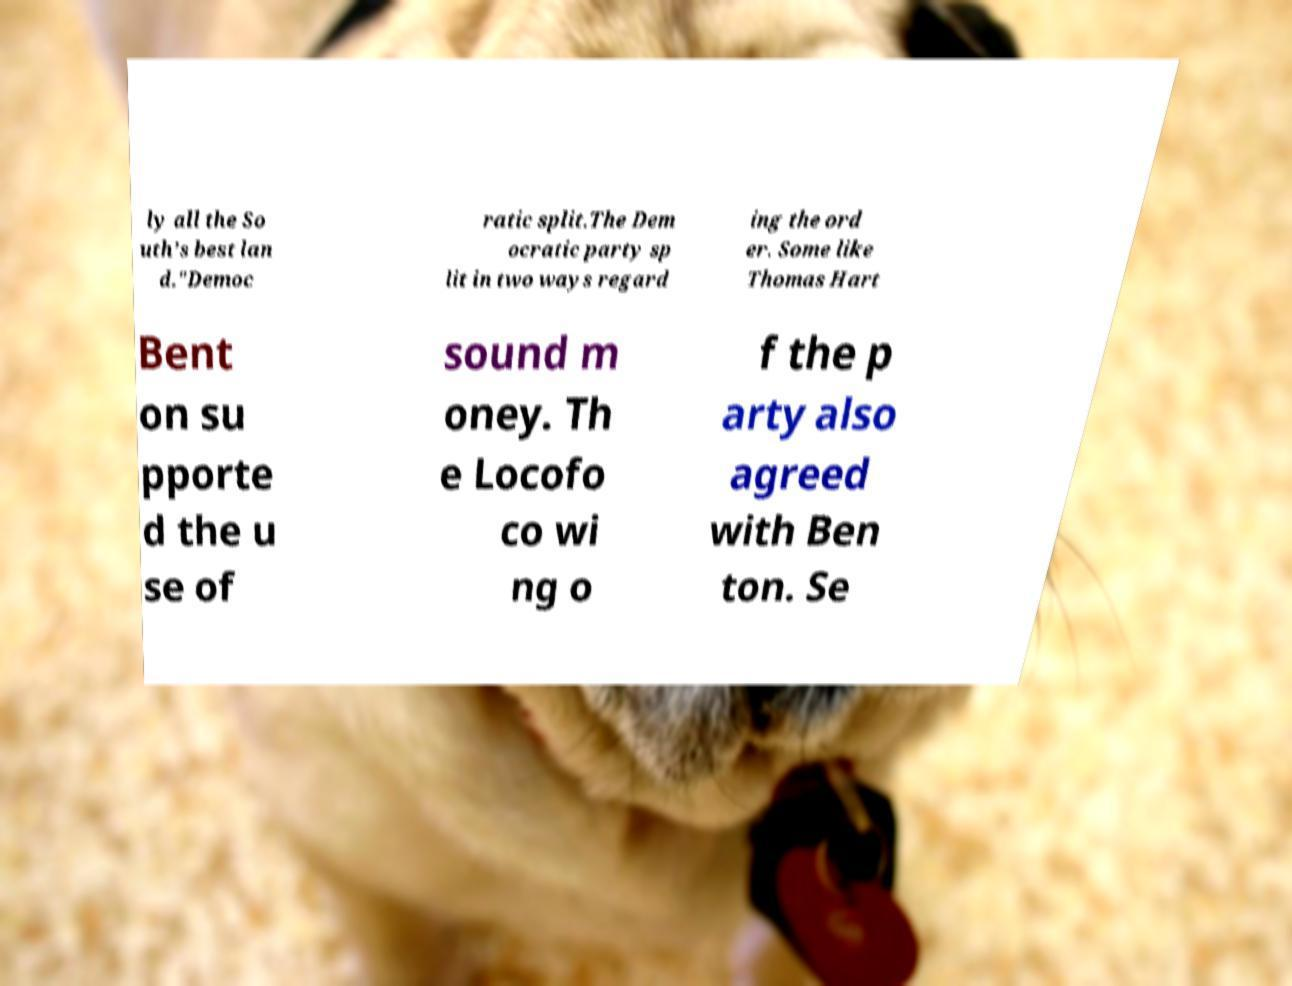For documentation purposes, I need the text within this image transcribed. Could you provide that? ly all the So uth’s best lan d."Democ ratic split.The Dem ocratic party sp lit in two ways regard ing the ord er. Some like Thomas Hart Bent on su pporte d the u se of sound m oney. Th e Locofo co wi ng o f the p arty also agreed with Ben ton. Se 